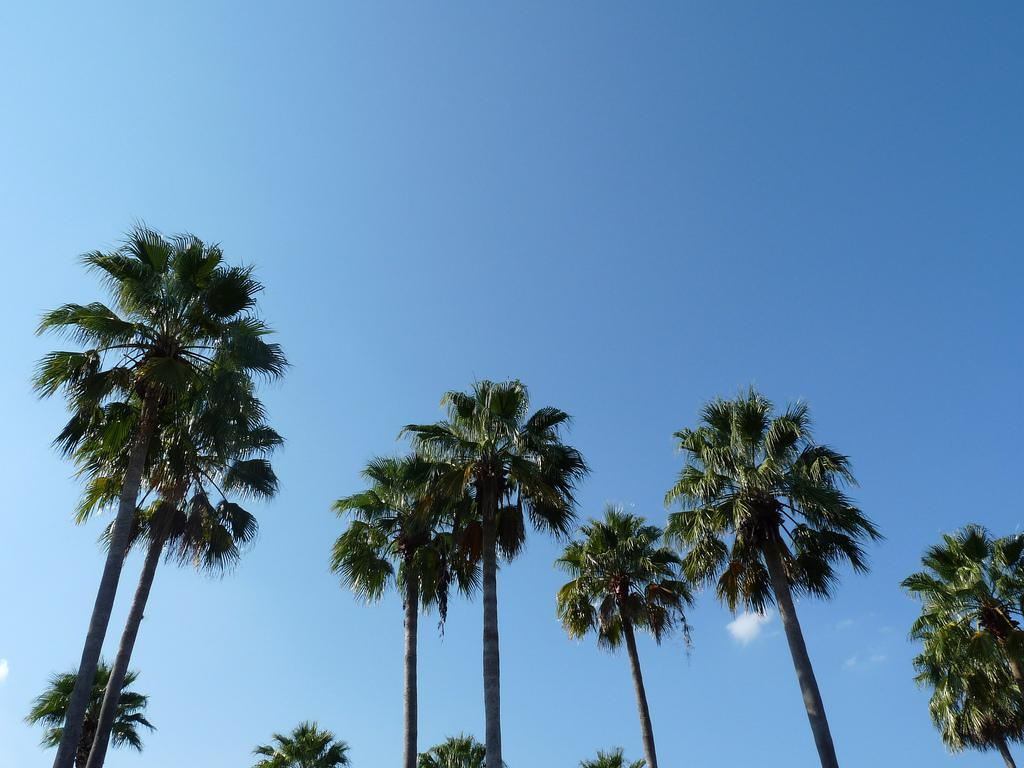What type of vegetation can be seen in the image? There are trees in the image. What is the condition of the sky in the image? The sky is clear in the image. What type of bell can be heard ringing in the image? There is no bell present in the image, and therefore no sound can be heard. 